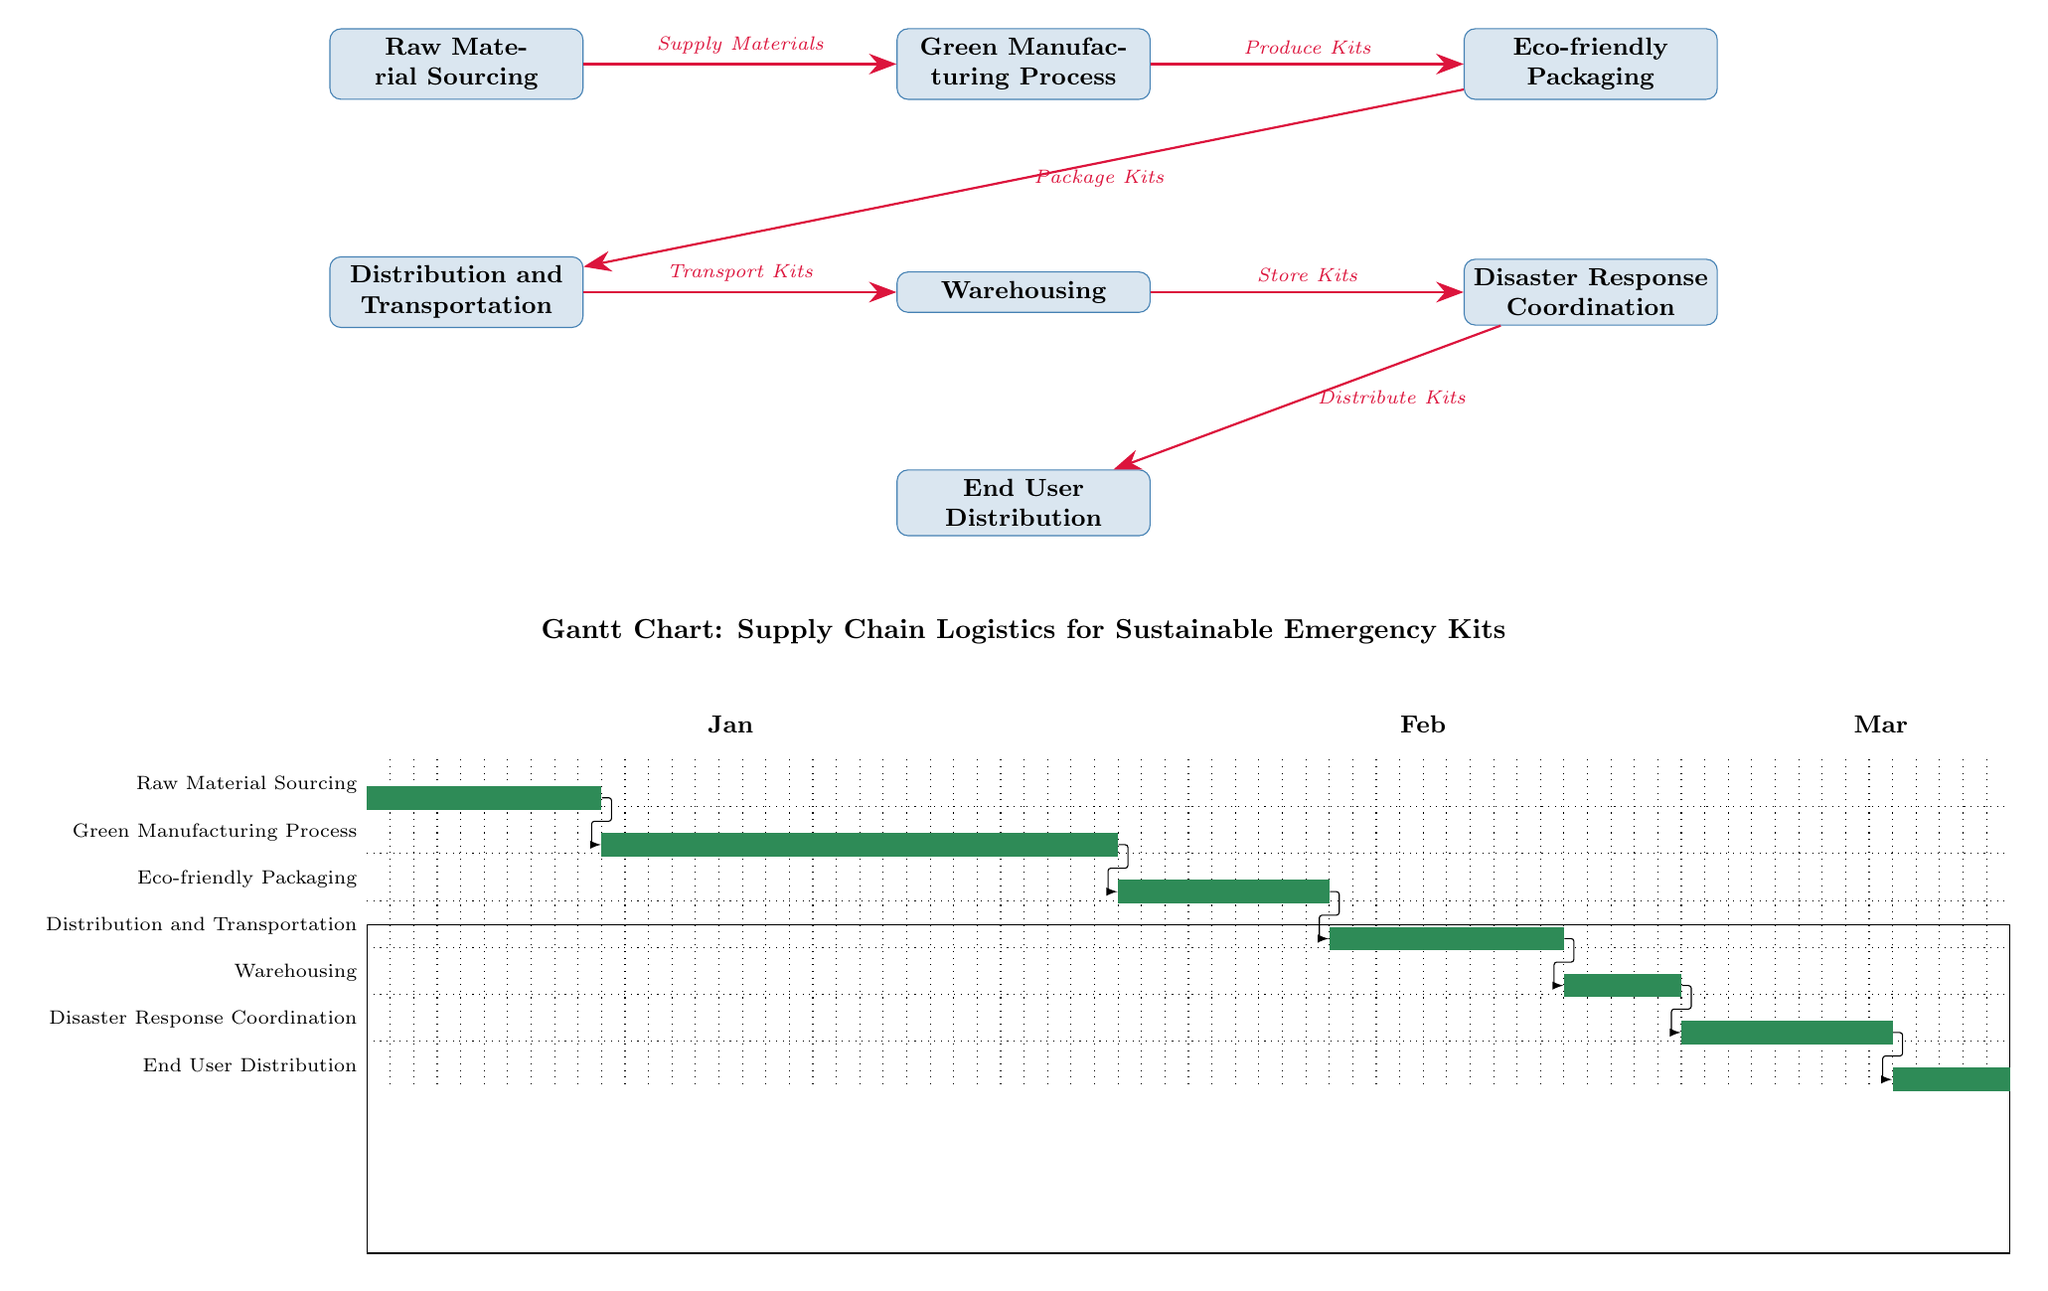What is the duration of Raw Material Sourcing? The Gantt chart shows that Raw Material Sourcing starts on day 1 and ends on day 10, making its duration 10 days.
Answer: 10 days What is the last task in the supply chain? The diagram indicates that the last task in the sequence, as represented on the Gantt chart, is End User Distribution.
Answer: End User Distribution How many tasks are shown in the Gantt chart? By counting the rectangles in the diagram, there are a total of 7 tasks listed in the Gantt chart.
Answer: 7 tasks Which task follows Eco-friendly Packaging? The edges in the diagram indicate that Directly after Eco-friendly Packaging is the Distribution and Transportation task.
Answer: Distribution and Transportation What is the start day of Disaster Response Coordination? The Gantt chart indicates that Disaster Response Coordination starts on day 57.
Answer: 57 Which two tasks are connected directly by an edge? Looking at the diagram, Raw Material Sourcing and Green Manufacturing Process are directly connected by an edge.
Answer: Raw Material Sourcing, Green Manufacturing Process What is the total number of edges in the diagram? By counting the connections (edges) between tasks in the diagram, there are a total of 6 edges in the sequence.
Answer: 6 edges What is the purpose of the Gantt chart in this diagram? The Gantt chart visually represents the timeline and scheduling of each task in the supply chain logistics for sustainable emergency kits.
Answer: Timeline and scheduling 